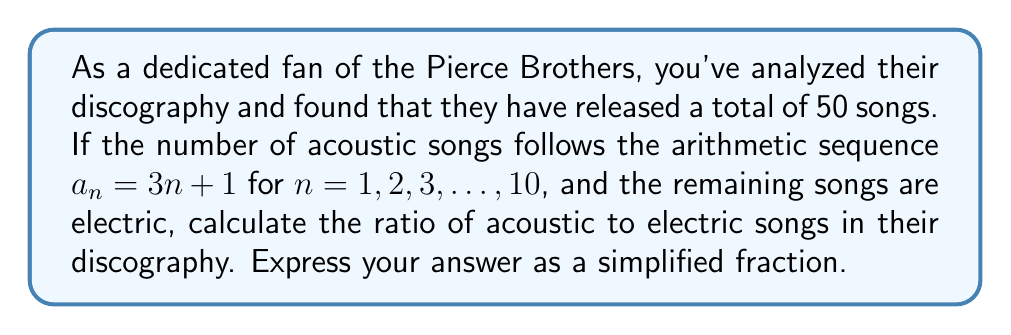Can you solve this math problem? Let's approach this step-by-step:

1) First, we need to find the total number of acoustic songs. We're given that the acoustic songs follow the arithmetic sequence $a_n = 3n + 1$ for $n = 1, 2, 3, ..., 10$.

2) To find the sum of this arithmetic sequence, we can use the formula:

   $$S_n = \frac{n}{2}(a_1 + a_n)$$

   where $S_n$ is the sum of the sequence, $n$ is the number of terms, $a_1$ is the first term, and $a_n$ is the last term.

3) In this case:
   $n = 10$
   $a_1 = 3(1) + 1 = 4$
   $a_{10} = 3(10) + 1 = 31$

4) Substituting these into our formula:

   $$S_{10} = \frac{10}{2}(4 + 31) = 5(35) = 175$$

5) So there are 175 acoustic songs.

6) We're told that there are 50 songs in total, so the number of electric songs is:

   $50 - 175 = 325$

7) The ratio of acoustic to electric songs is therefore 175:325

8) This can be simplified by dividing both numbers by their greatest common divisor (GCD).
   The GCD of 175 and 325 is 25.

   $175 ÷ 25 = 7$
   $325 ÷ 25 = 13$

9) Therefore, the simplified ratio is 7:13
Answer: $\frac{7}{13}$ 